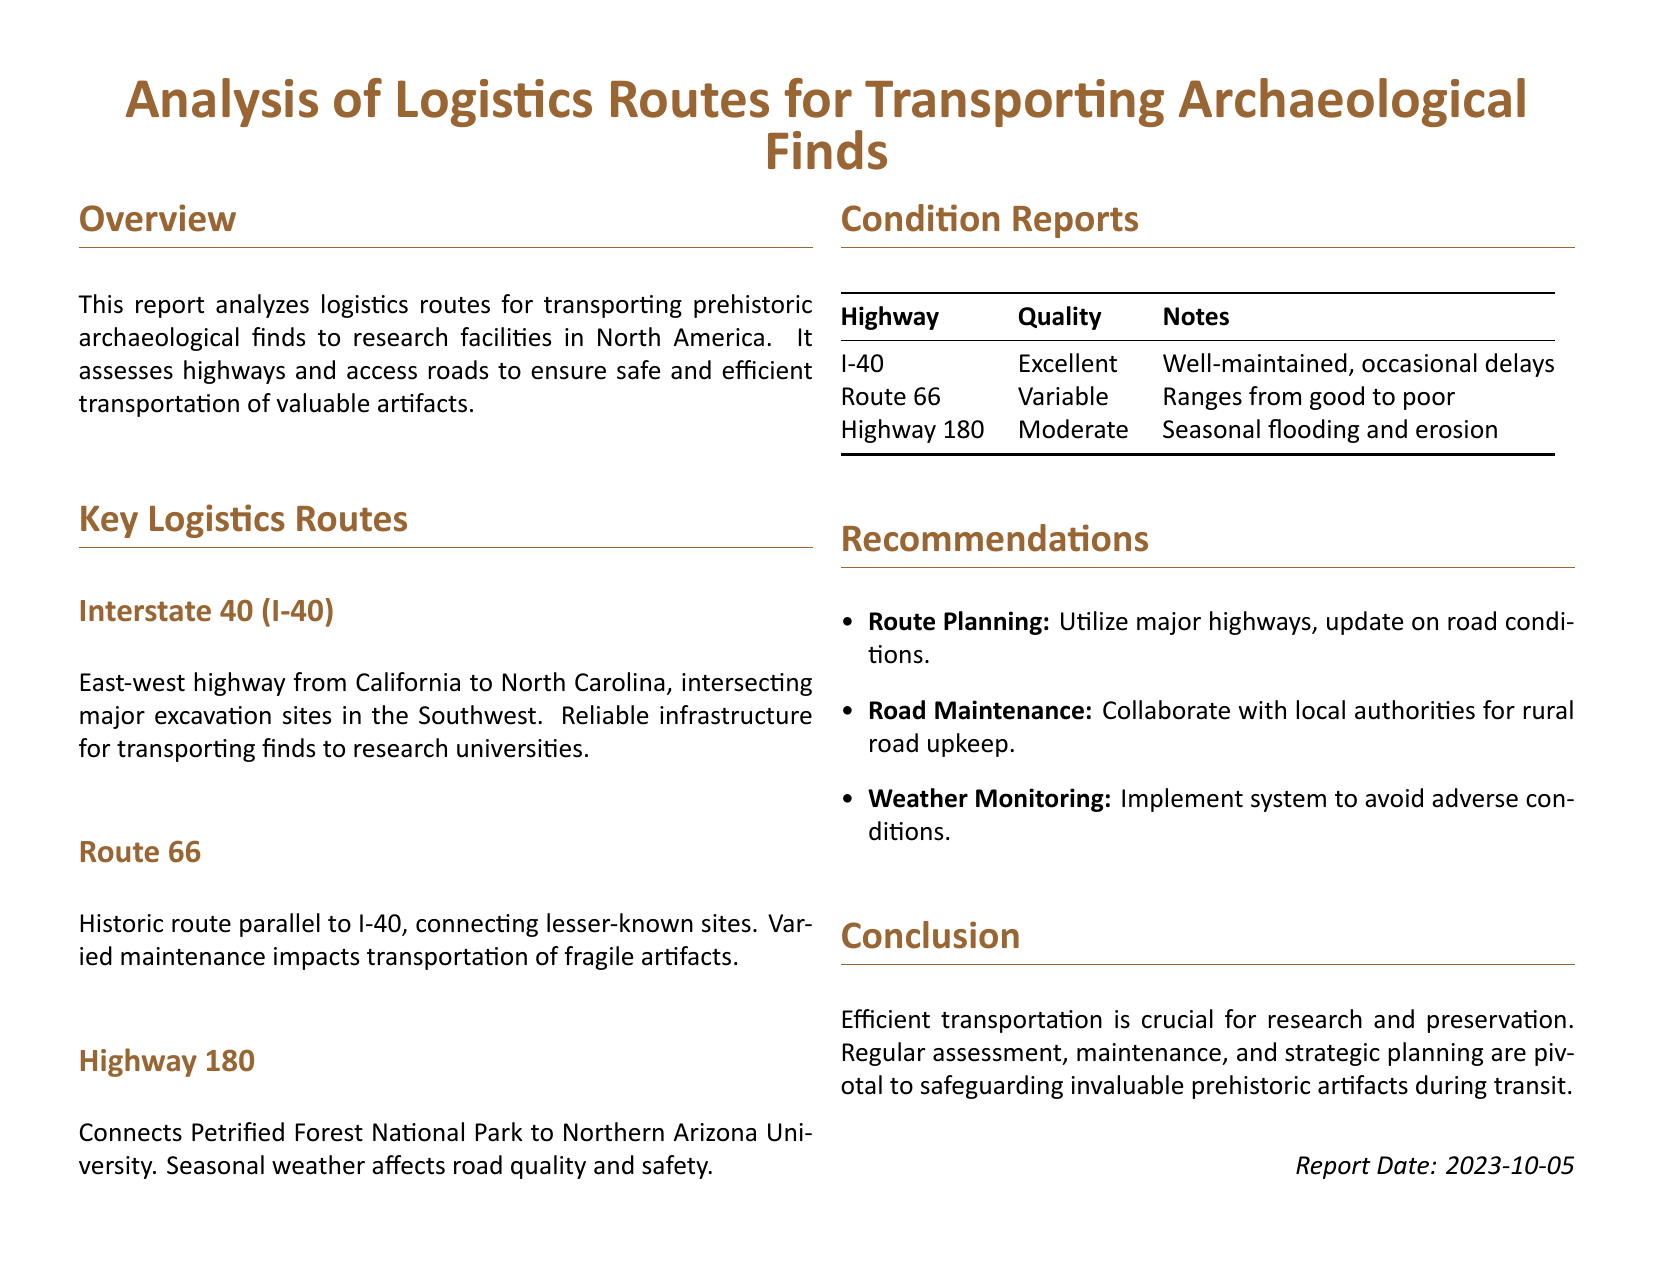What is the title of the report? The title of the report is the primary heading that summarizes the document's purpose.
Answer: Analysis of Logistics Routes for Transporting Archaeological Finds What is the condition of Interstate 40? The condition of Interstate 40 is summarized in the condition reports table, which reflects overall quality and maintenance status.
Answer: Excellent What are the seasonal impacts on Highway 180? The seasonal impacts on Highway 180 are noted under the condition reports, focusing on weather-related issues affecting road safety.
Answer: Seasonal flooding and erosion How many key logistics routes are identified in the report? The number of key logistics routes can be counted from the sections detailing each route in the document.
Answer: Three Which highway connects Petrified Forest National Park to a university? This highway is specifically mentioned in the context of connecting archaeological sites to research facilities.
Answer: Highway 180 What type of road maintenance is recommended in the report? The recommendation for road maintenance addresses collaborative efforts for upkeep.
Answer: Collaborate with local authorities When was the report dated? The report date is indicated at the bottom of the document, providing a timestamp for the information presented.
Answer: 2023-10-05 What does the report suggest for weather monitoring? The report includes a recommendation that specifically pertains to weather conditions affecting transportation.
Answer: Implement system to avoid adverse conditions 